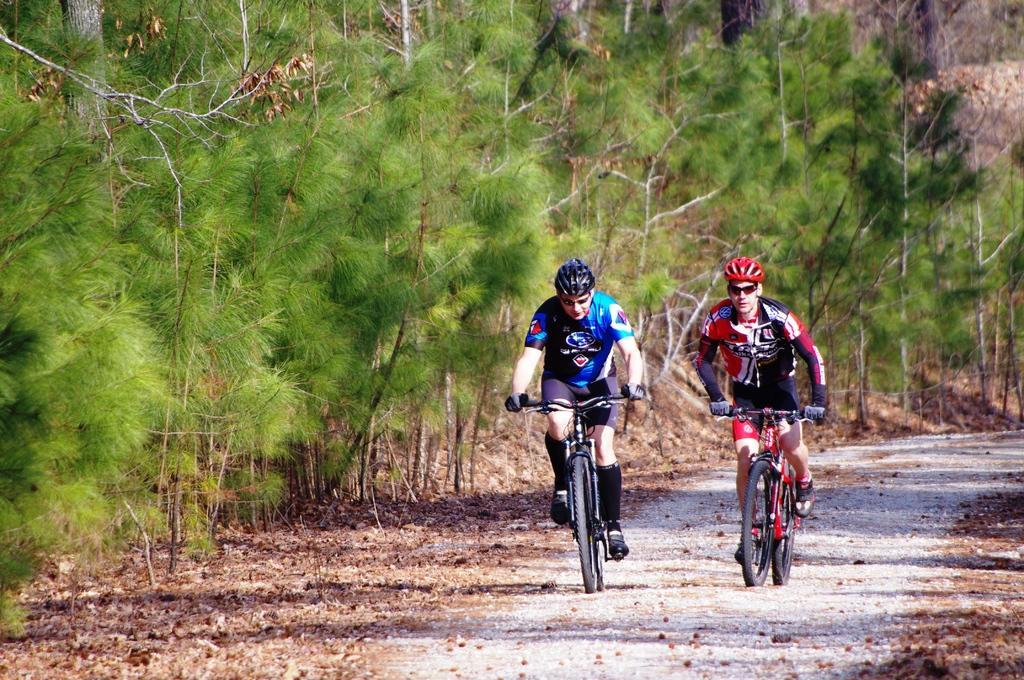In one or two sentences, can you explain what this image depicts? In this image two persons wearing helmets are riding bikes on a path. In the background there are trees. In the background there are trees. On the ground there are dried leaves. 